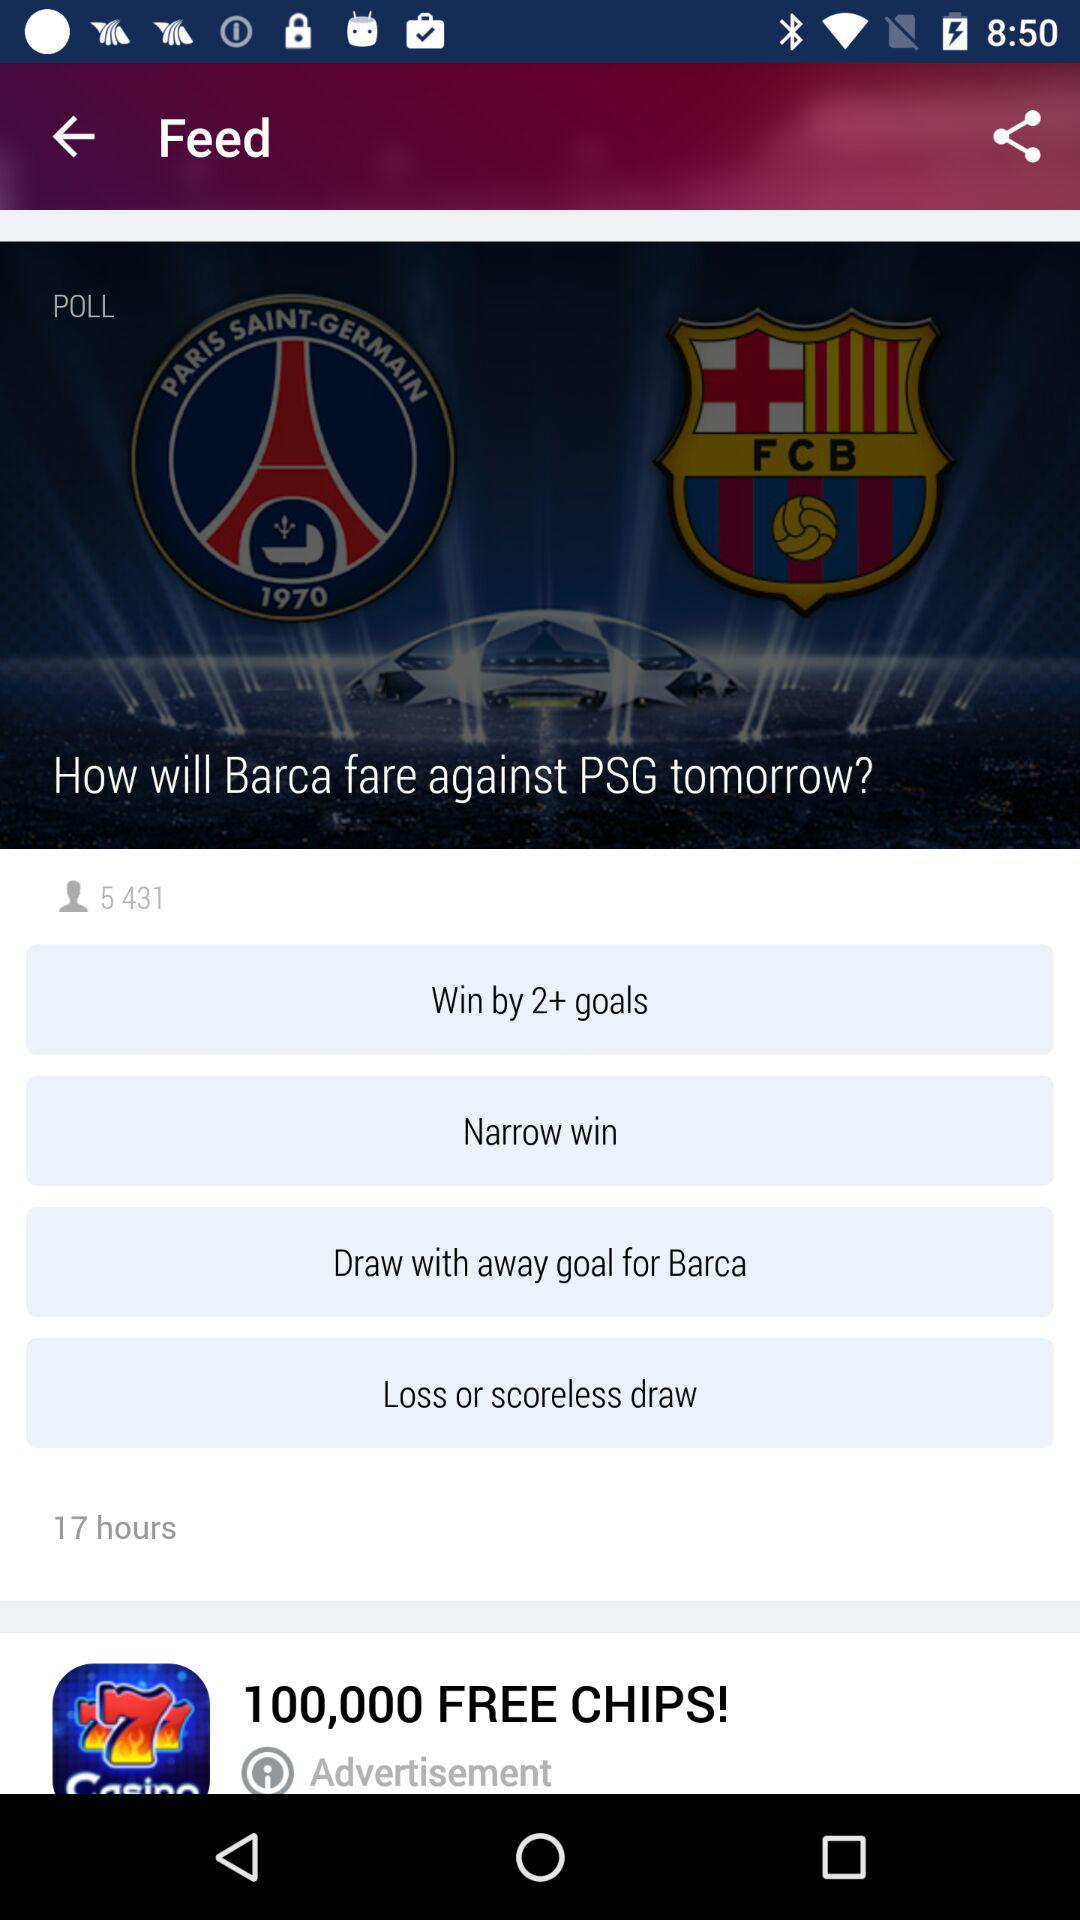What's the total number of viewers? The total number of viewers is 5,431. 